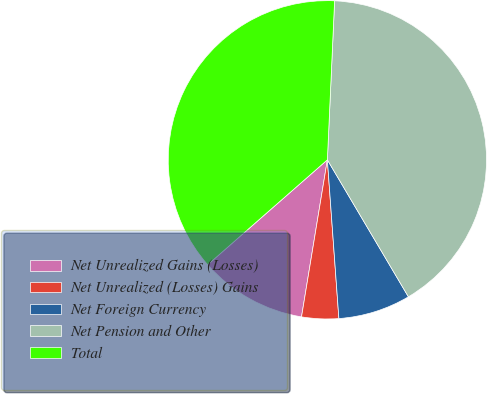Convert chart to OTSL. <chart><loc_0><loc_0><loc_500><loc_500><pie_chart><fcel>Net Unrealized Gains (Losses)<fcel>Net Unrealized (Losses) Gains<fcel>Net Foreign Currency<fcel>Net Pension and Other<fcel>Total<nl><fcel>10.95%<fcel>3.75%<fcel>7.35%<fcel>40.78%<fcel>37.18%<nl></chart> 